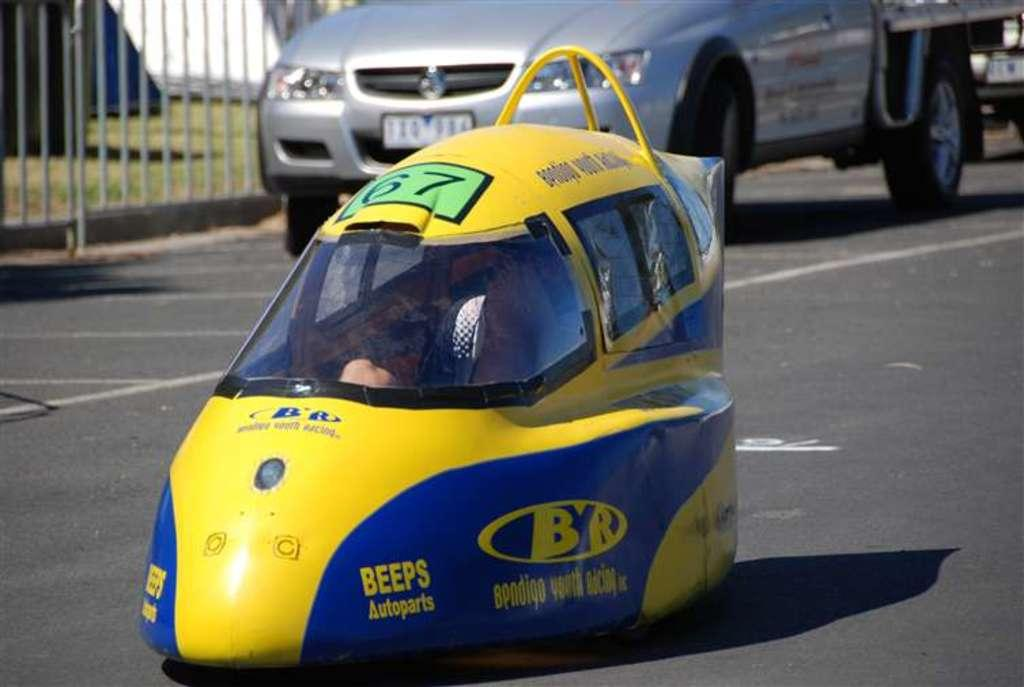<image>
Create a compact narrative representing the image presented. A yellow and blue vehicle says Beeps autoparts. 